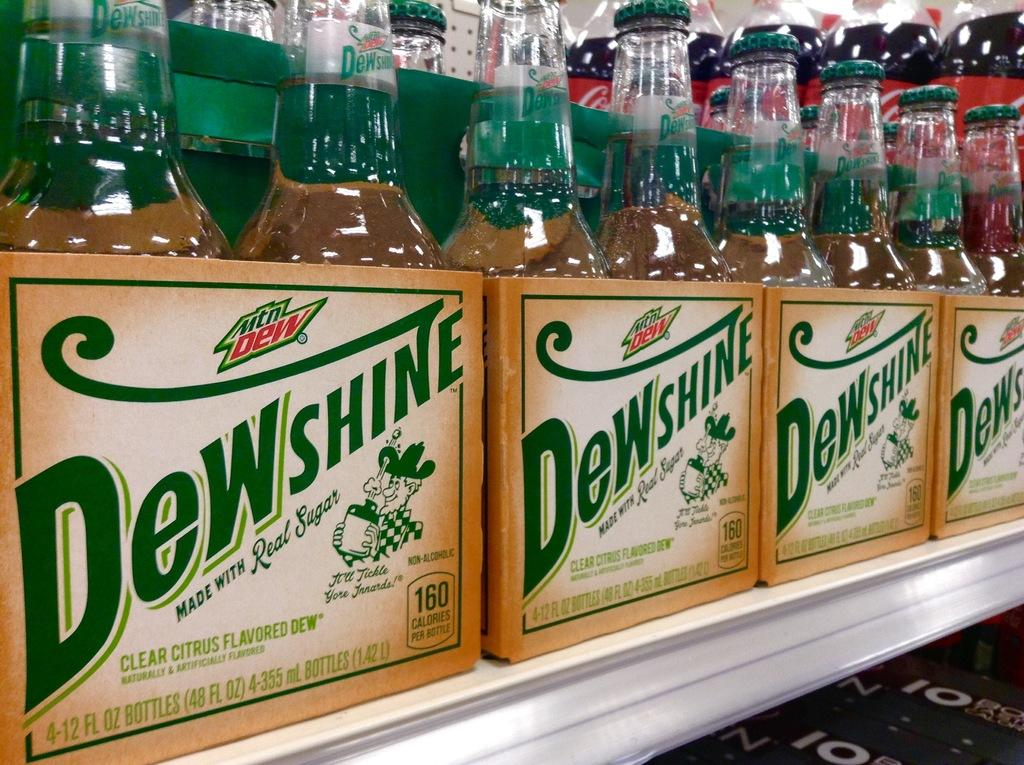Provide a one-sentence caption for the provided image. Multiple packages of a clear citrus flavoured drink by a brand called Dewshine. 